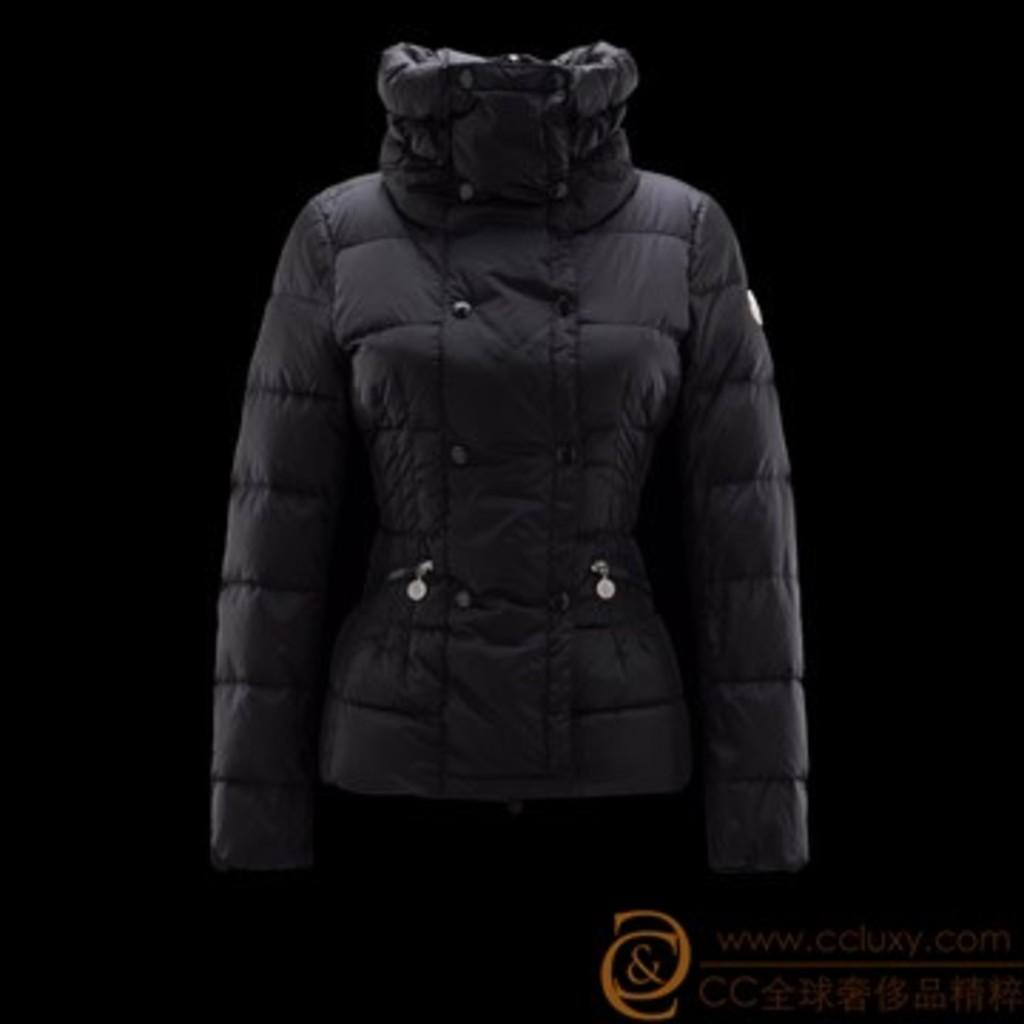What type of clothing is visible in the image? There is a black color jacket in the image. What color is the background of the image? The background of the image is black. What type of chair is depicted in the image? There is no chair present in the image; it only features a black color jacket and a black background. 